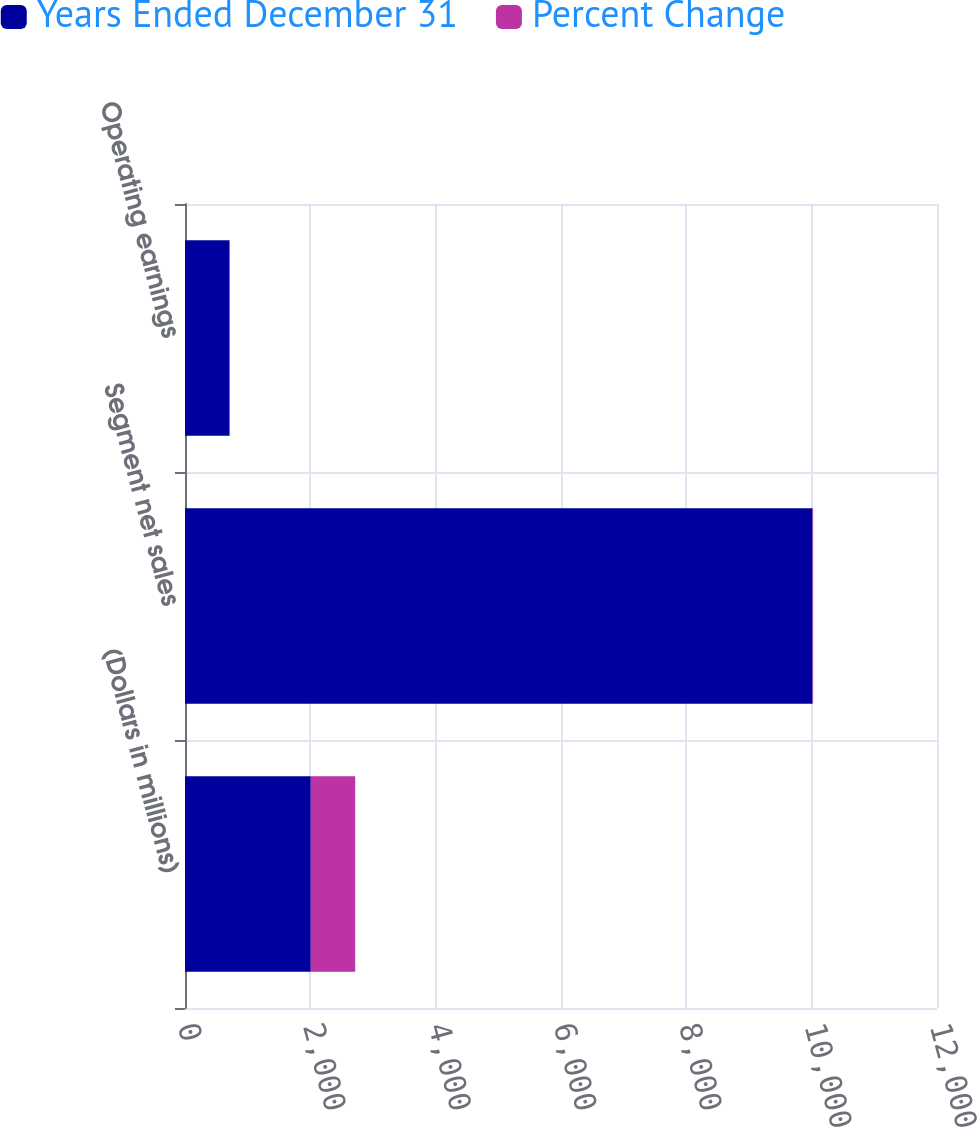Convert chart. <chart><loc_0><loc_0><loc_500><loc_500><stacked_bar_chart><ecel><fcel>(Dollars in millions)<fcel>Segment net sales<fcel>Operating earnings<nl><fcel>Years Ended December 31<fcel>2007<fcel>10014<fcel>709<nl><fcel>Percent Change<fcel>709<fcel>9<fcel>10<nl></chart> 